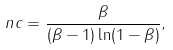Convert formula to latex. <formula><loc_0><loc_0><loc_500><loc_500>\ n c = \frac { \beta } { ( \beta - 1 ) \ln ( 1 - \beta ) } ,</formula> 